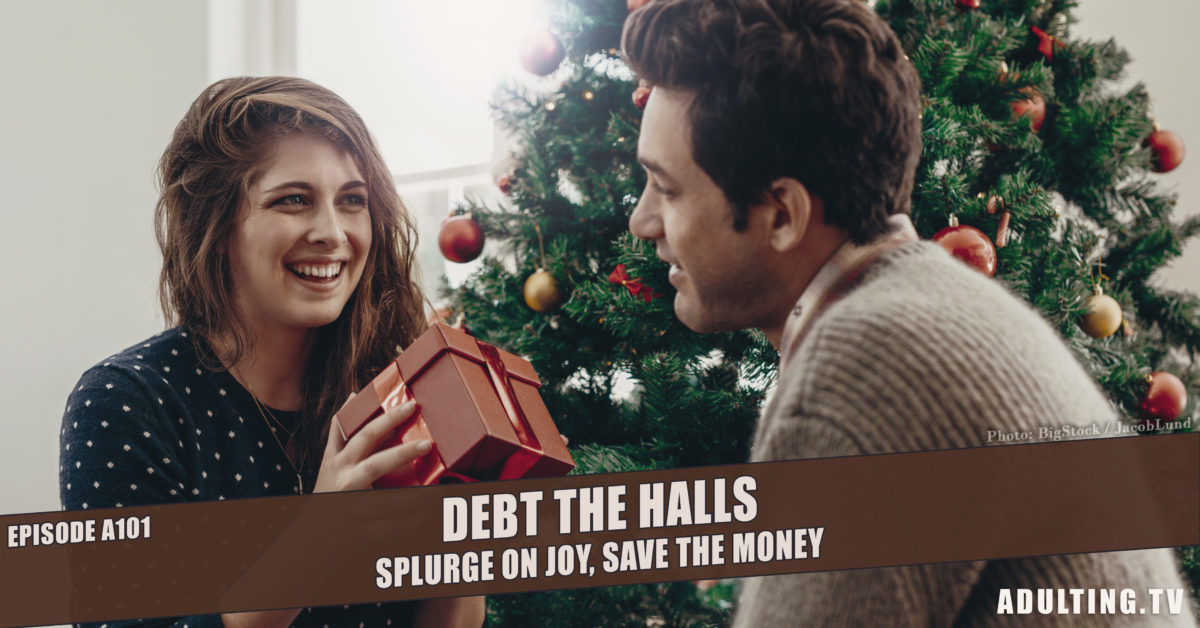Are there any specific elements in their clothing that relate to the holiday season? Yes, their clothing subtly reflects the holiday season. The man wears a sweater, fitting for the cooler December temperatures typically associated with Christmas in many regions. The woman's attire, while not overtly holiday-themed, is casual and comfortable, suitable for a home setting during a relaxed festive gathering. 